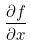Convert formula to latex. <formula><loc_0><loc_0><loc_500><loc_500>\frac { \partial f } { \partial x }</formula> 